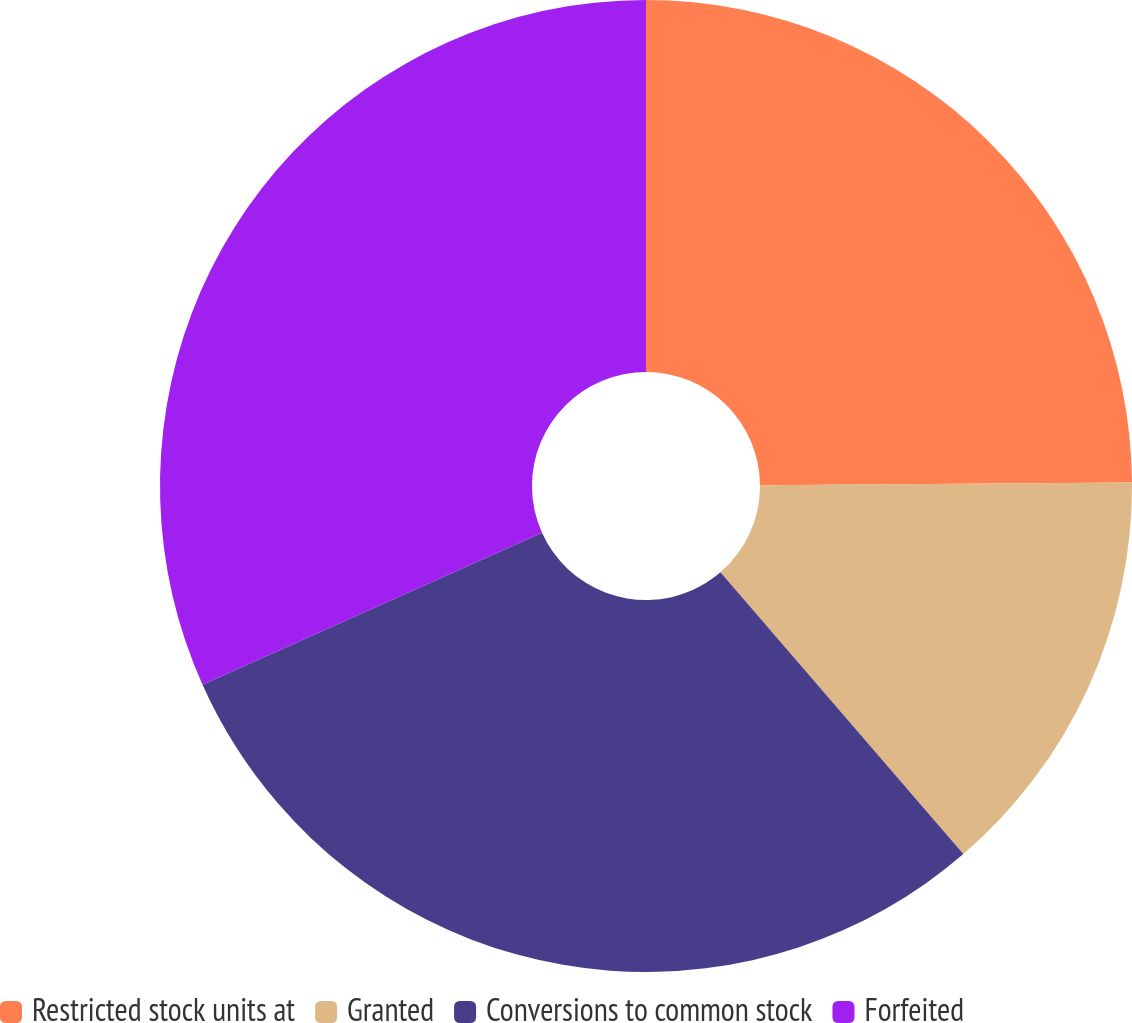<chart> <loc_0><loc_0><loc_500><loc_500><pie_chart><fcel>Restricted stock units at<fcel>Granted<fcel>Conversions to common stock<fcel>Forfeited<nl><fcel>24.89%<fcel>13.79%<fcel>29.62%<fcel>31.71%<nl></chart> 